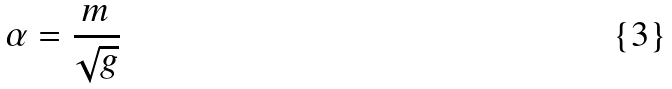Convert formula to latex. <formula><loc_0><loc_0><loc_500><loc_500>\alpha = \frac { m } { \sqrt { g } }</formula> 